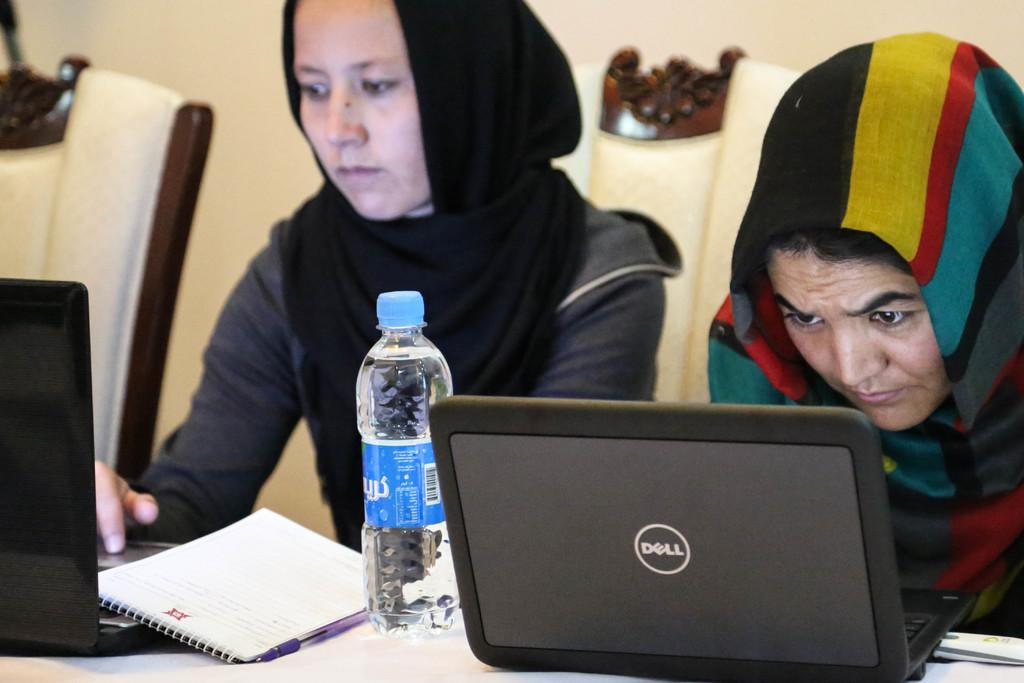How many people are in the image? There are two men in the image. What are the men doing in the image? The men are sitting and observing a laptop. Can you describe the clothing the men are wearing? The men are wearing hijabs. What is present on the table in the image? There is a water bottle on the table. What is visible behind the men in the image? There is a wall behind the men. What type of waves can be seen crashing on the shore in the image? There are no waves or shore visible in the image; it features two men sitting and observing a laptop. 